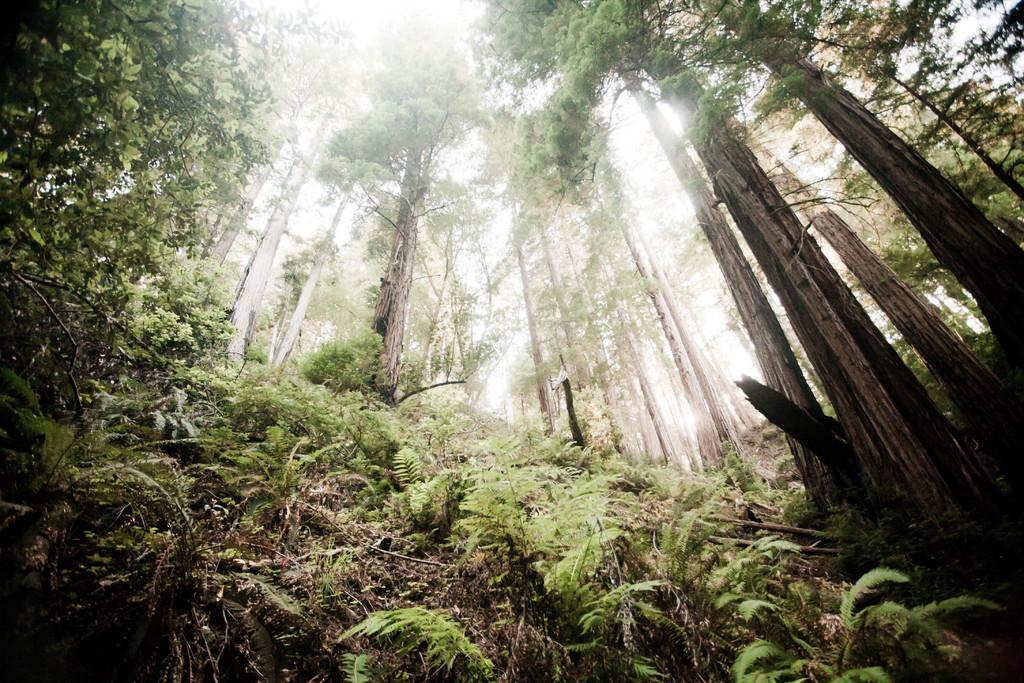In one or two sentences, can you explain what this image depicts? In this image I can see many trees and the sky. 